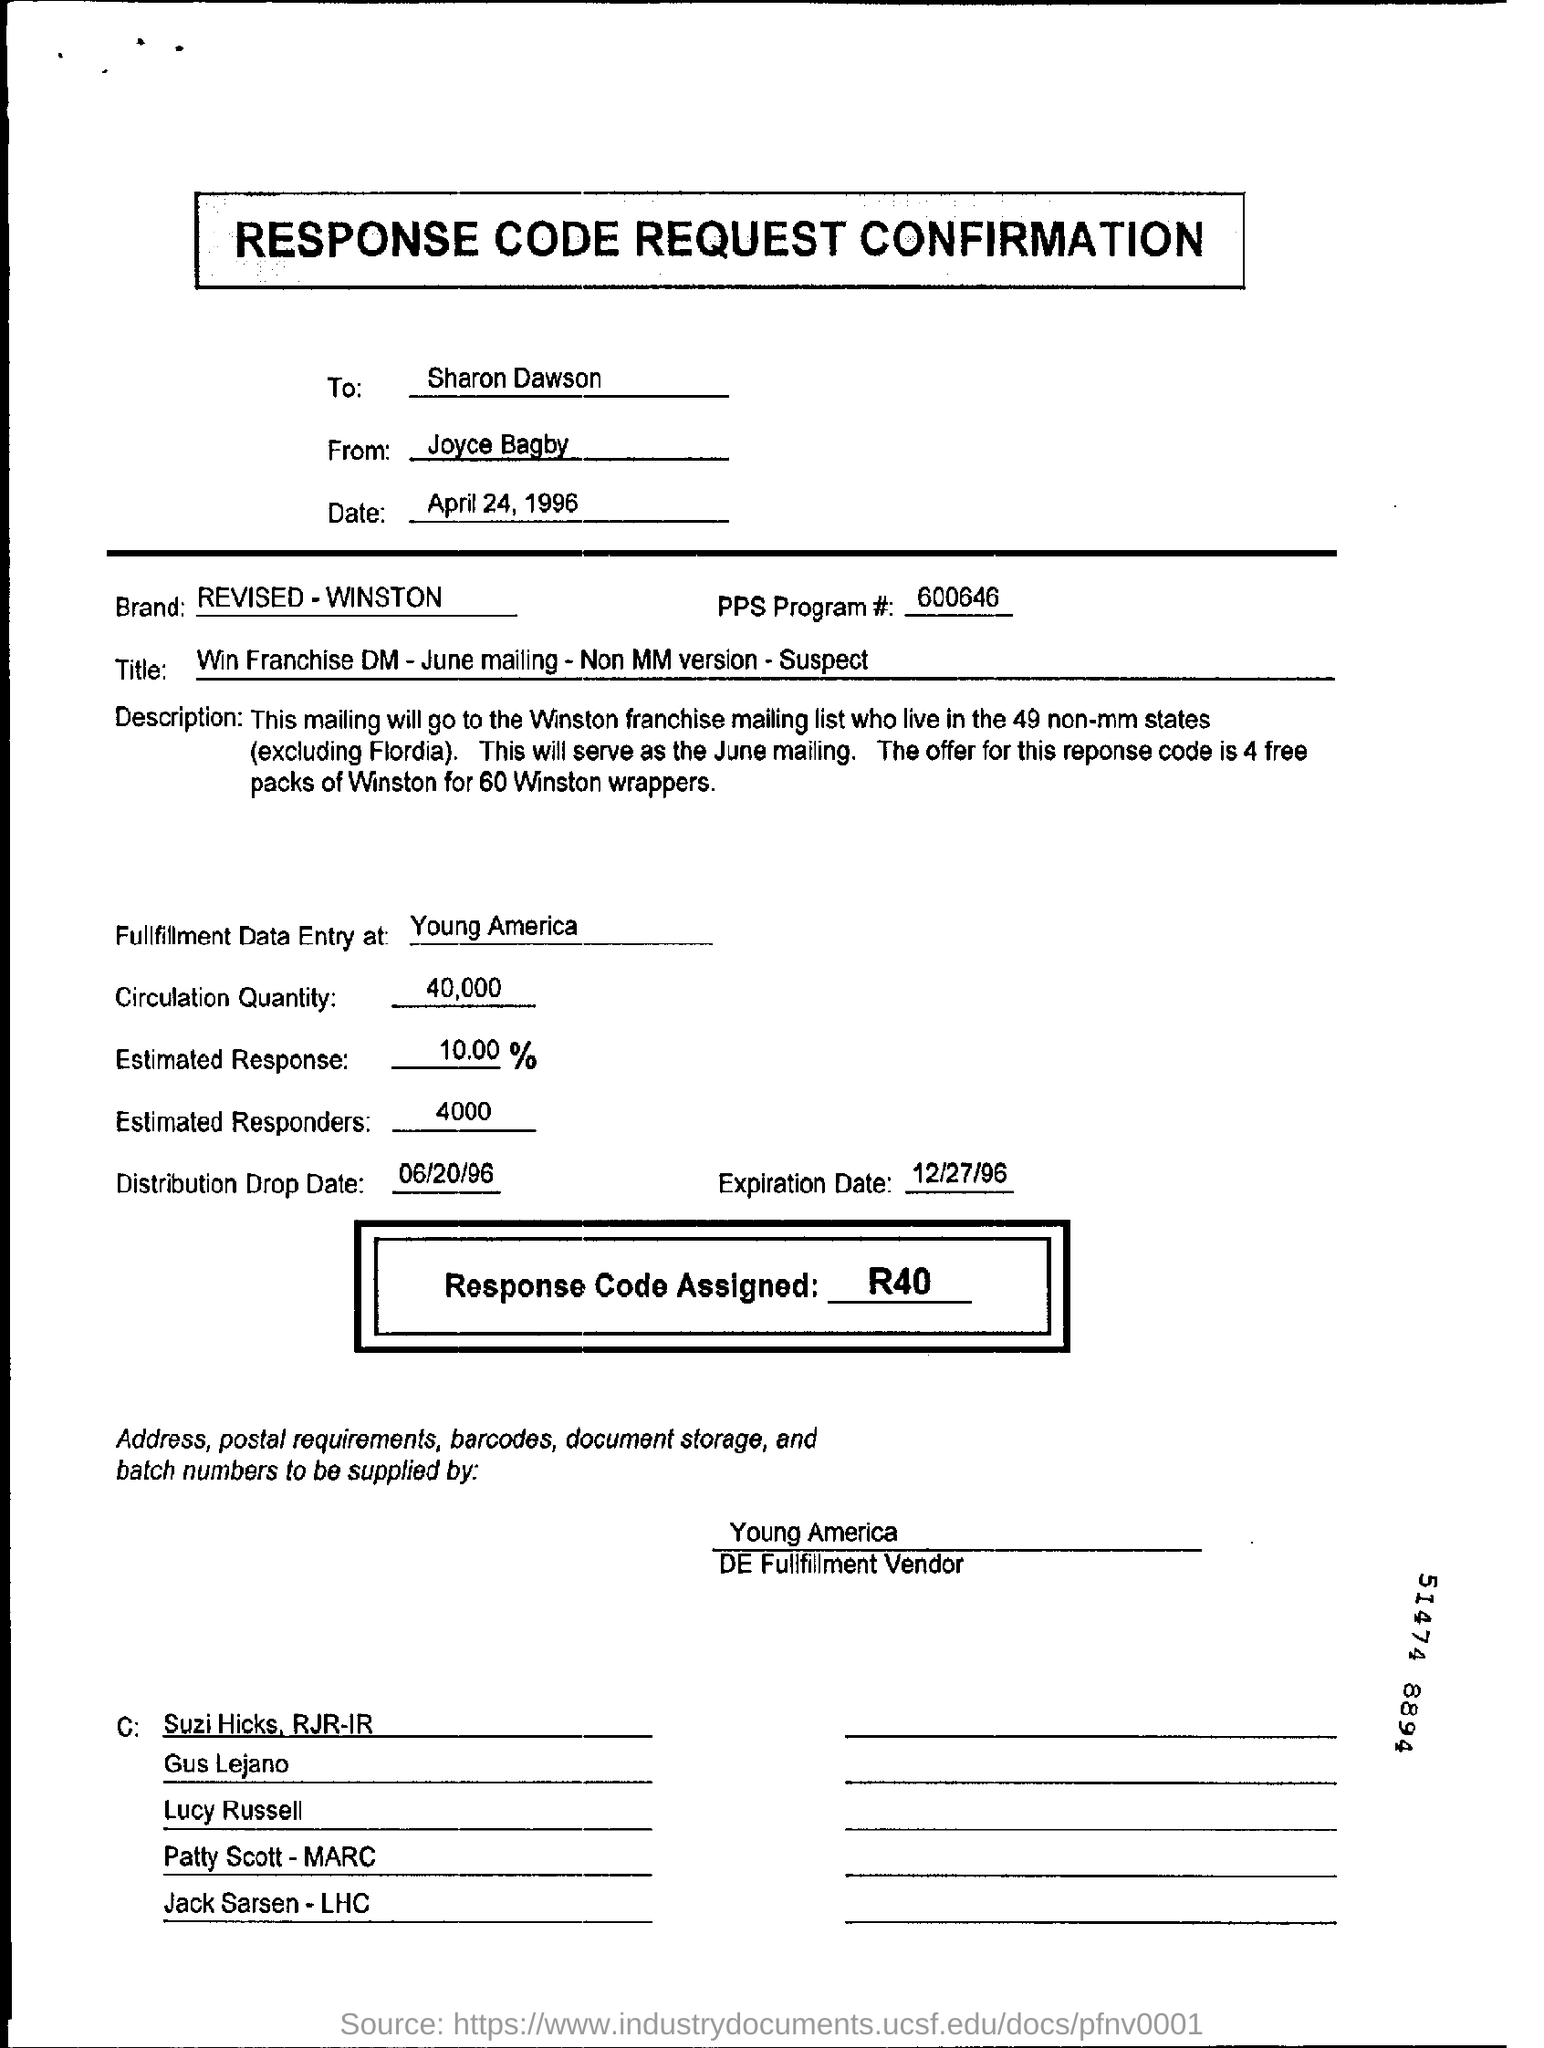Who is the sender of the response code request confirmation?
Provide a short and direct response. Joyce Bagby. What date is the response code request confirmation sent?
Provide a short and direct response. April 24, 1996. To whom is the response code request confirmation sent?
Provide a short and direct response. Sharan Dawson. What is the response code assigned?
Keep it short and to the point. R40. What is the brand for the response code request confirmation?
Your answer should be compact. REVISED - WINSTON. What is the title mentioned in the document?
Make the answer very short. Win Franchise DM - June mailing - Non MM version - Suspect. What is the circulation quantity?
Offer a very short reply. 40,000. Where is the fulfilment data entry done?
Make the answer very short. Young america. What is the distribution drop date?
Offer a very short reply. 06/20/96. What is the expiration date?
Offer a very short reply. 12/27/96. 